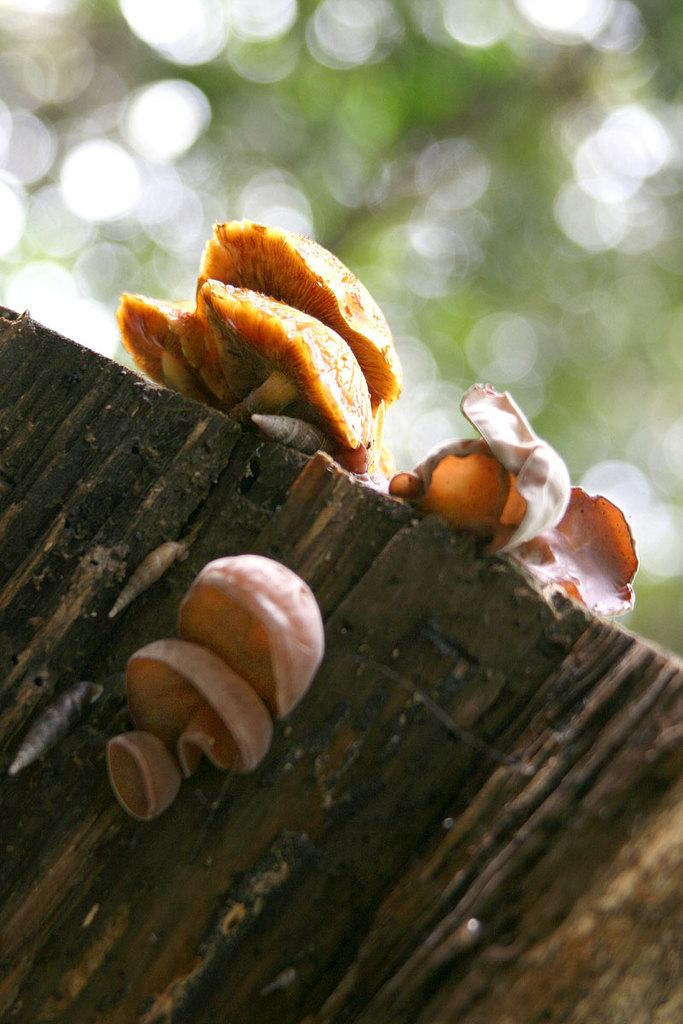What type of fungi can be seen on the wood in the image? There are mushrooms on the wood in the image. Can you describe the background of the image? The background of the image is blurred. What type of plastic material can be seen floating in space in the image? There is no plastic material or space depicted in the image; it features mushrooms on wood with a blurred background. 